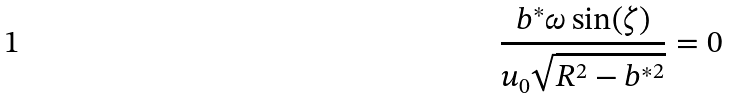<formula> <loc_0><loc_0><loc_500><loc_500>\frac { b ^ { * } \omega \sin ( \zeta ) } { u _ { 0 } \sqrt { R ^ { 2 } - b ^ { * 2 } } } = 0</formula> 